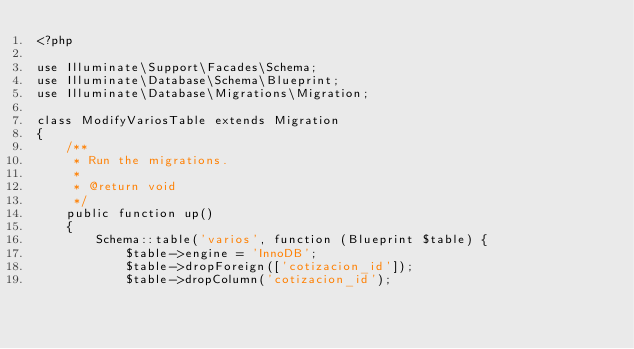Convert code to text. <code><loc_0><loc_0><loc_500><loc_500><_PHP_><?php

use Illuminate\Support\Facades\Schema;
use Illuminate\Database\Schema\Blueprint;
use Illuminate\Database\Migrations\Migration;

class ModifyVariosTable extends Migration
{
    /**
     * Run the migrations.
     *
     * @return void
     */
    public function up()
    {
        Schema::table('varios', function (Blueprint $table) {
            $table->engine = 'InnoDB';
            $table->dropForeign(['cotizacion_id']);
            $table->dropColumn('cotizacion_id');</code> 